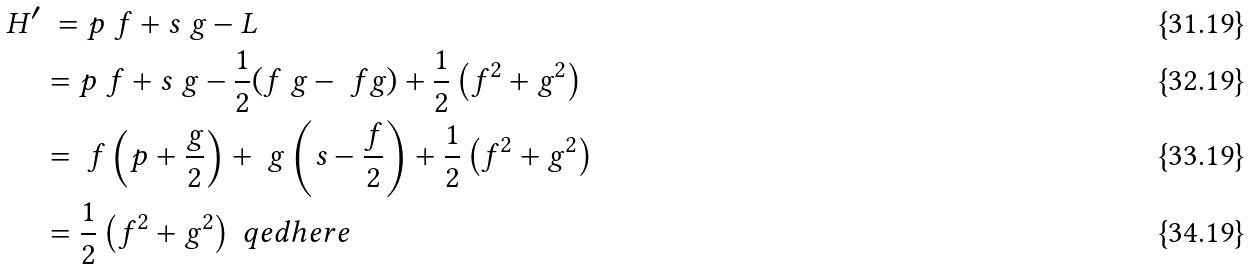<formula> <loc_0><loc_0><loc_500><loc_500>H ^ { \prime } & \ = p \ f + s \ g - L \\ & = p \ f + s \ g - \frac { 1 } { 2 } ( f \ g - \ f g ) + \frac { 1 } { 2 } \left ( f ^ { 2 } + g ^ { 2 } \right ) \\ & = \ f \left ( p + \frac { g } { 2 } \right ) + \ g \left ( s - \frac { f } { 2 } \right ) + \frac { 1 } { 2 } \left ( f ^ { 2 } + g ^ { 2 } \right ) \\ & = \frac { 1 } { 2 } \left ( f ^ { 2 } + g ^ { 2 } \right ) \ q e d h e r e</formula> 